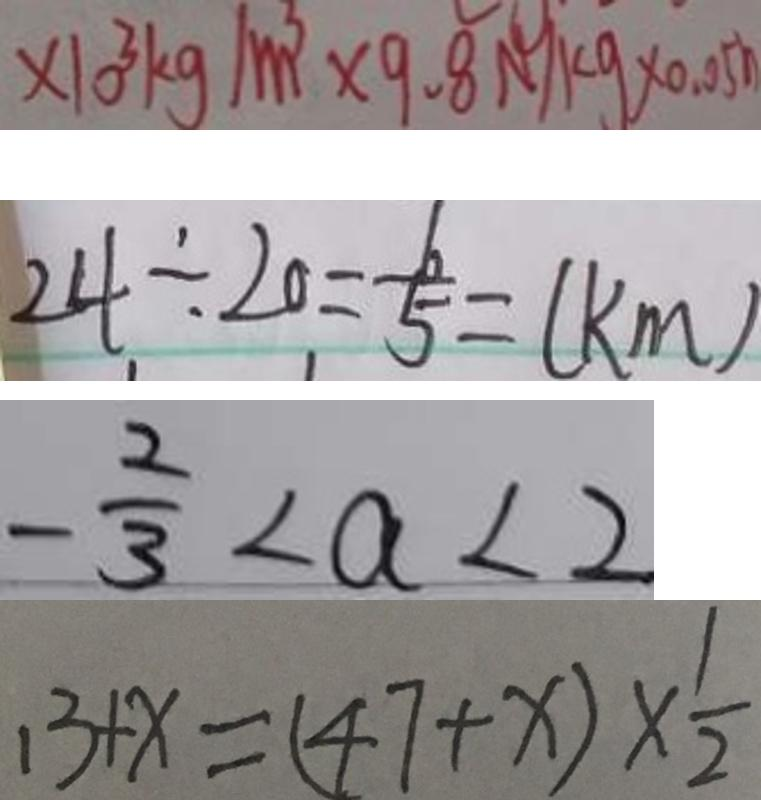<formula> <loc_0><loc_0><loc_500><loc_500>\times 1 0 ^ { 3 } k g / m ^ { 3 } \times 9 . 8 N / k g \times 0 . 0 5 h 
 2 4 \div 2 0 = \frac { 6 } { 5 } = ( k m ) 
 - \frac { 2 } { 3 } < a < 2 
 1 3 + x = ( 4 7 + x ) \times \frac { 1 } { 2 }</formula> 